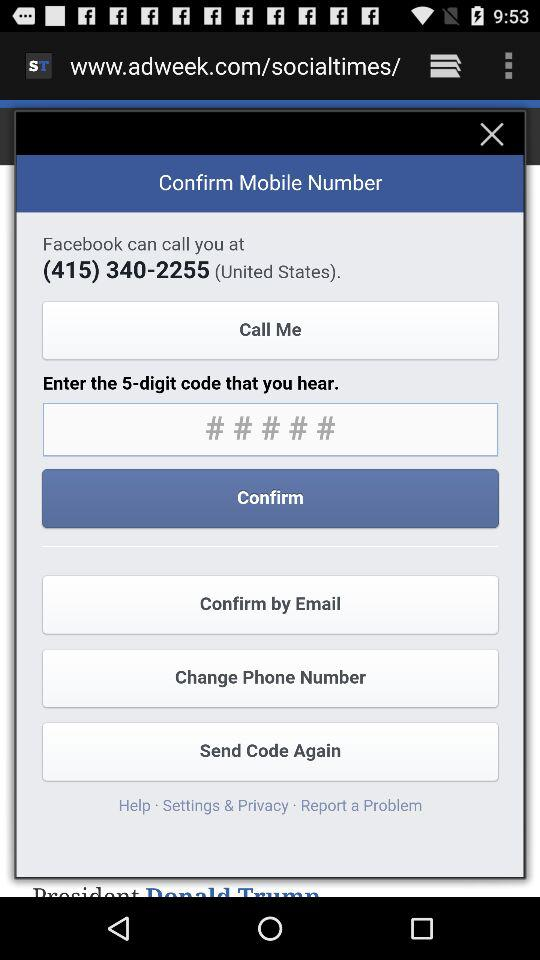What number can "Facebook" call? The number is (415) 340-2255. 